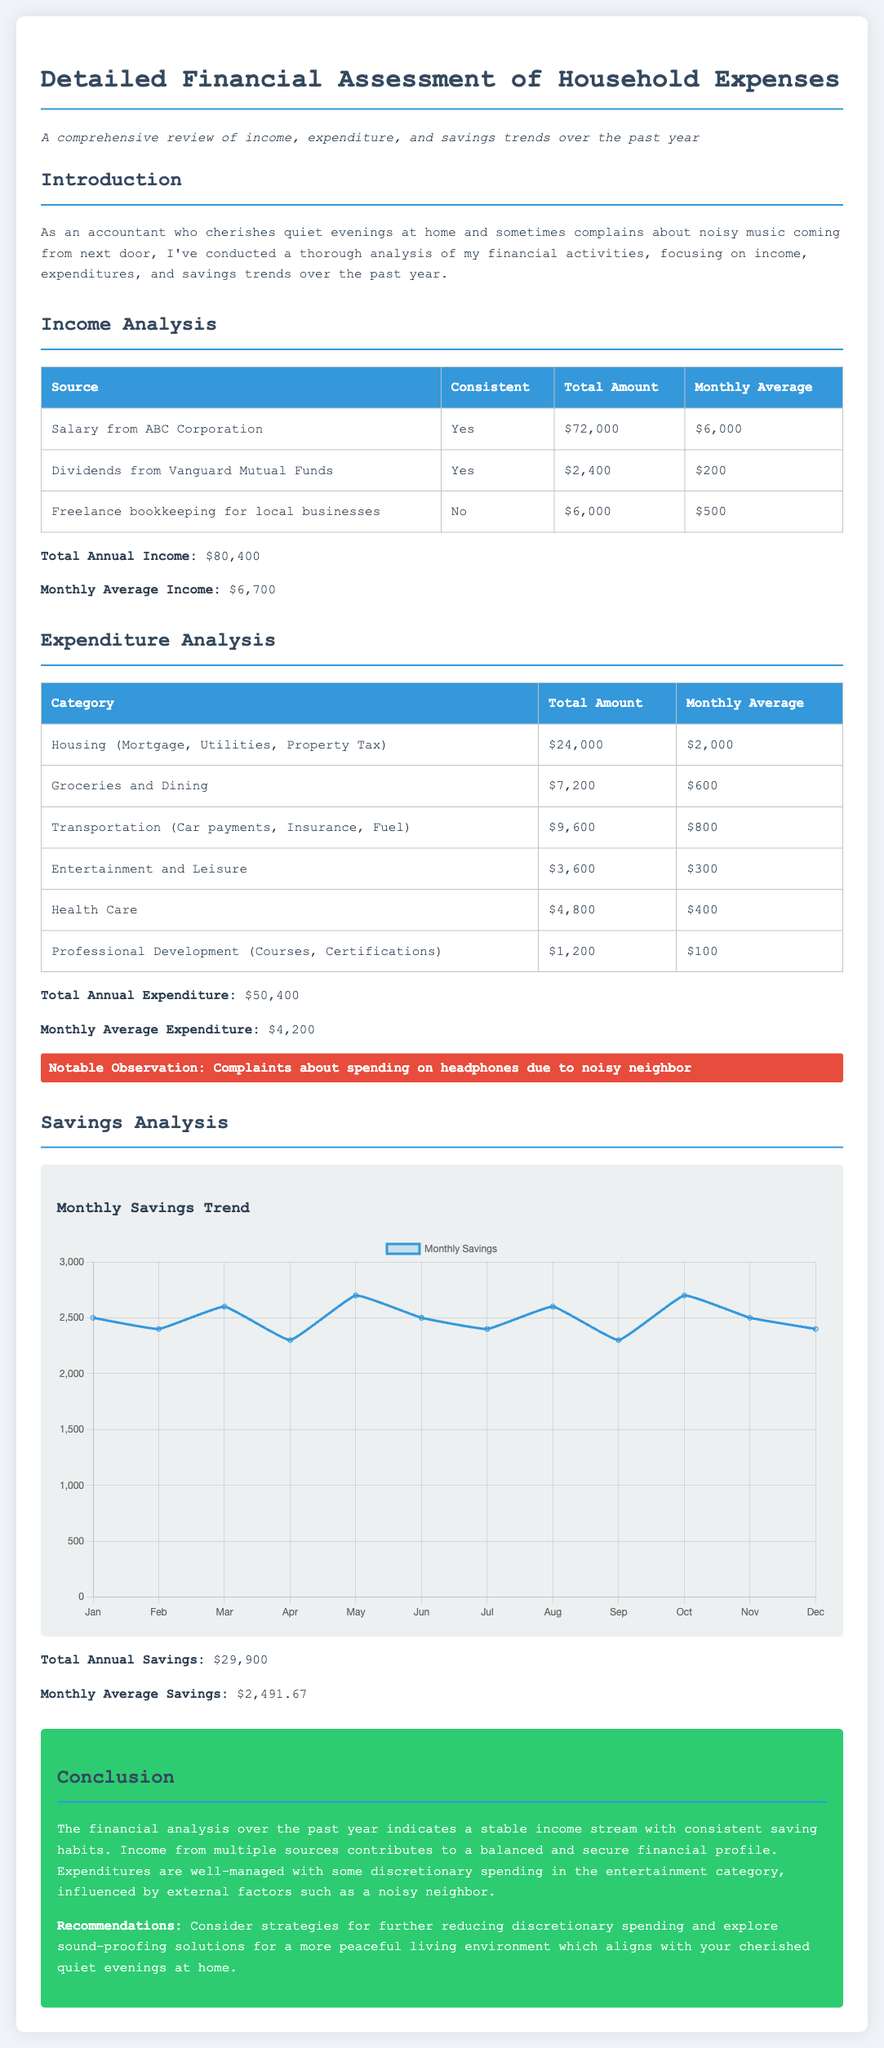what is the total annual income? The total annual income is calculated by adding all income sources listed in the document, which amounts to $72,000 + $2,400 + $6,000.
Answer: $80,400 what is the monthly average expenditure? The monthly average expenditure is derived from the total annual expenditure divided by 12 months, which amounts to $50,400 ÷ 12.
Answer: $4,200 which category has the highest expenditure? The expenditure category with the highest amount is Housing, totaling $24,000.
Answer: Housing what is the monthly average income? The monthly average income is found by dividing the total annual income by 12 months, calculated as $80,400 ÷ 12.
Answer: $6,700 what notable observation is made regarding spending due to external factors? The notable observation specifically mentions spending on headphones due to noise from a neighbor.
Answer: Complaints about spending on headphones due to noisy neighbor what was the total amount spent on groceries and dining? The total amount spent on groceries and dining can be found from the expenditure table, which shows $7,200.
Answer: $7,200 how much was saved monthly on average? The monthly average savings can be identified as total annual savings divided by 12, which is $29,900 ÷ 12.
Answer: $2,491.67 how many sources of income are consistent? The document lists two income sources that are consistent: Salary from ABC Corporation and Dividends from Vanguard Mutual Funds.
Answer: 2 what is recommended for improving the living environment? The recommendation mentioned in the conclusion suggests exploring sound-proofing solutions.
Answer: Sound-proofing solutions 